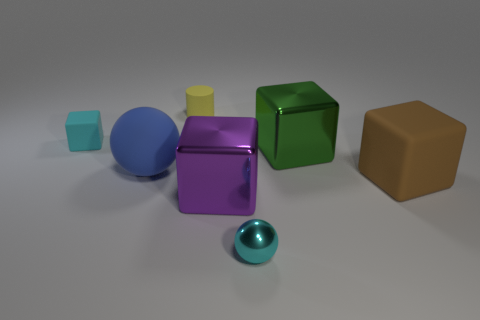There is a matte cube on the left side of the object behind the small block; how big is it?
Provide a succinct answer. Small. What color is the rubber thing that is both right of the blue rubber sphere and left of the brown matte object?
Keep it short and to the point. Yellow. What material is the cyan block that is the same size as the cyan metal ball?
Your answer should be compact. Rubber. How many other things are the same material as the cyan block?
Your answer should be compact. 3. There is a matte block left of the brown object; does it have the same color as the large metal thing that is right of the cyan shiny sphere?
Offer a very short reply. No. There is a cyan thing that is behind the object right of the green object; what shape is it?
Provide a succinct answer. Cube. How many other things are there of the same color as the small cube?
Your response must be concise. 1. Are the sphere to the right of the yellow matte thing and the small block that is to the left of the yellow cylinder made of the same material?
Keep it short and to the point. No. What size is the rubber cube behind the big sphere?
Give a very brief answer. Small. What is the material of the green thing that is the same shape as the brown rubber object?
Offer a terse response. Metal. 